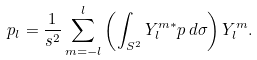<formula> <loc_0><loc_0><loc_500><loc_500>p _ { l } = \frac { 1 } { s ^ { 2 } } \sum _ { m = - l } ^ { l } \left ( \int _ { S ^ { 2 } } Y _ { l } ^ { m * } p \, d \sigma \right ) Y _ { l } ^ { m } .</formula> 